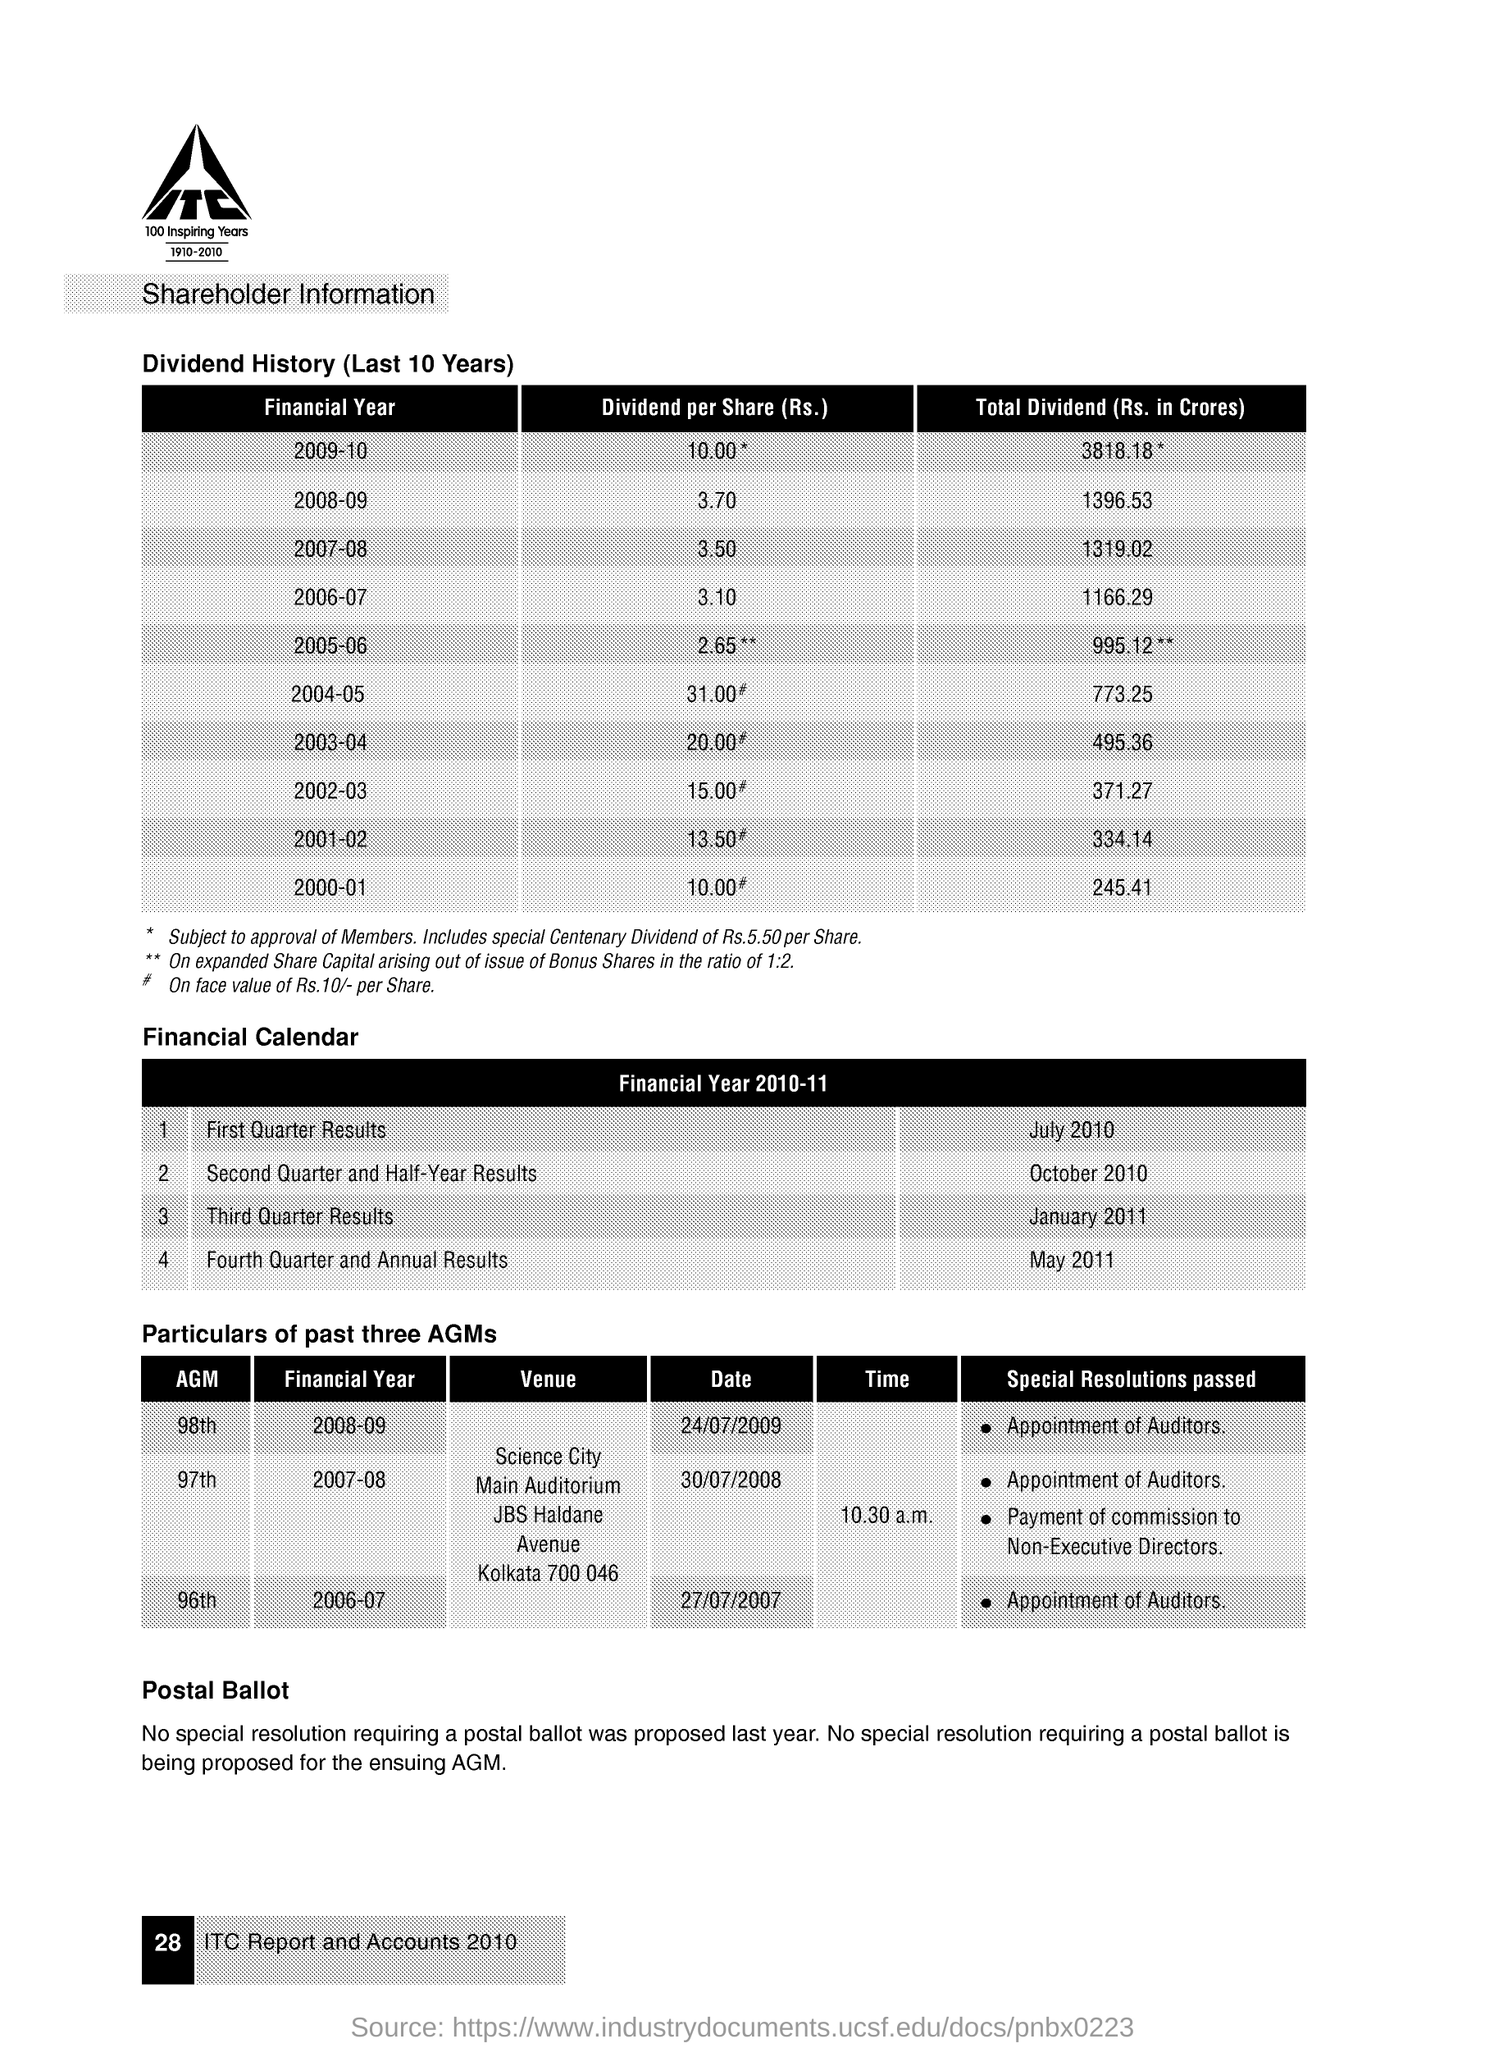What is the Dividend per Share(Rs.) for the Financial Year 2008-09?
Offer a terse response. 3.70. What is the Total Dividend (Rs. in Crores) for the Financial Year 2007-08?
Ensure brevity in your answer.  1319.02. What is the Dividend per Share(Rs.) for the Financial Year 2006-07?
Give a very brief answer. 3.10. What is the Total Dividend (Rs. in Crores) for the Financial Year 2006-07?
Your answer should be compact. 1166.29. When is the First Quarter Results announced for the Financial Year 2010-11?
Your response must be concise. July 2010. When is the Third Quarter Results announced for the Financial Year 2010-11?
Your answer should be very brief. January 2011. When is the 98th AGM conducted for the Financial Year 2008-09?
Give a very brief answer. 24/07/2009. 